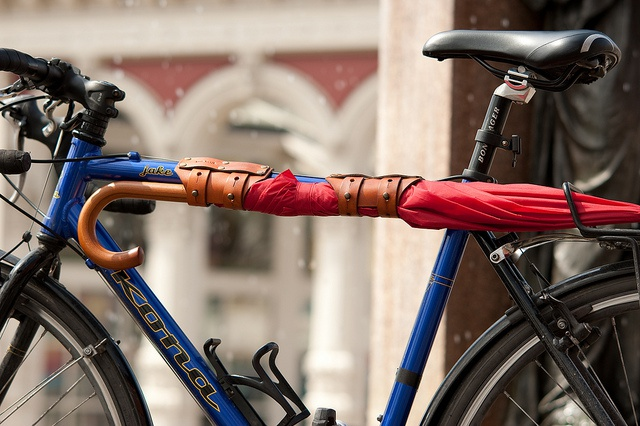Describe the objects in this image and their specific colors. I can see bicycle in gray, black, darkgray, and ivory tones and umbrella in gray, maroon, brown, and salmon tones in this image. 